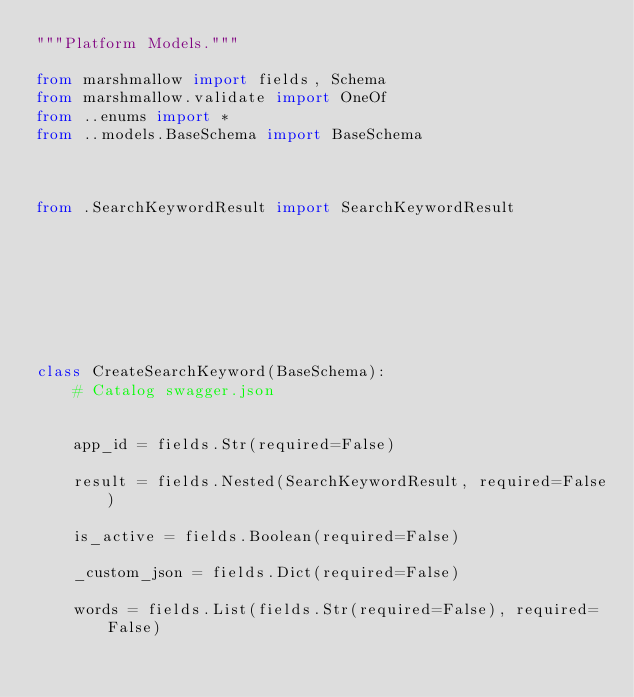Convert code to text. <code><loc_0><loc_0><loc_500><loc_500><_Python_>"""Platform Models."""

from marshmallow import fields, Schema
from marshmallow.validate import OneOf
from ..enums import *
from ..models.BaseSchema import BaseSchema



from .SearchKeywordResult import SearchKeywordResult








class CreateSearchKeyword(BaseSchema):
    # Catalog swagger.json

    
    app_id = fields.Str(required=False)
    
    result = fields.Nested(SearchKeywordResult, required=False)
    
    is_active = fields.Boolean(required=False)
    
    _custom_json = fields.Dict(required=False)
    
    words = fields.List(fields.Str(required=False), required=False)
    

</code> 